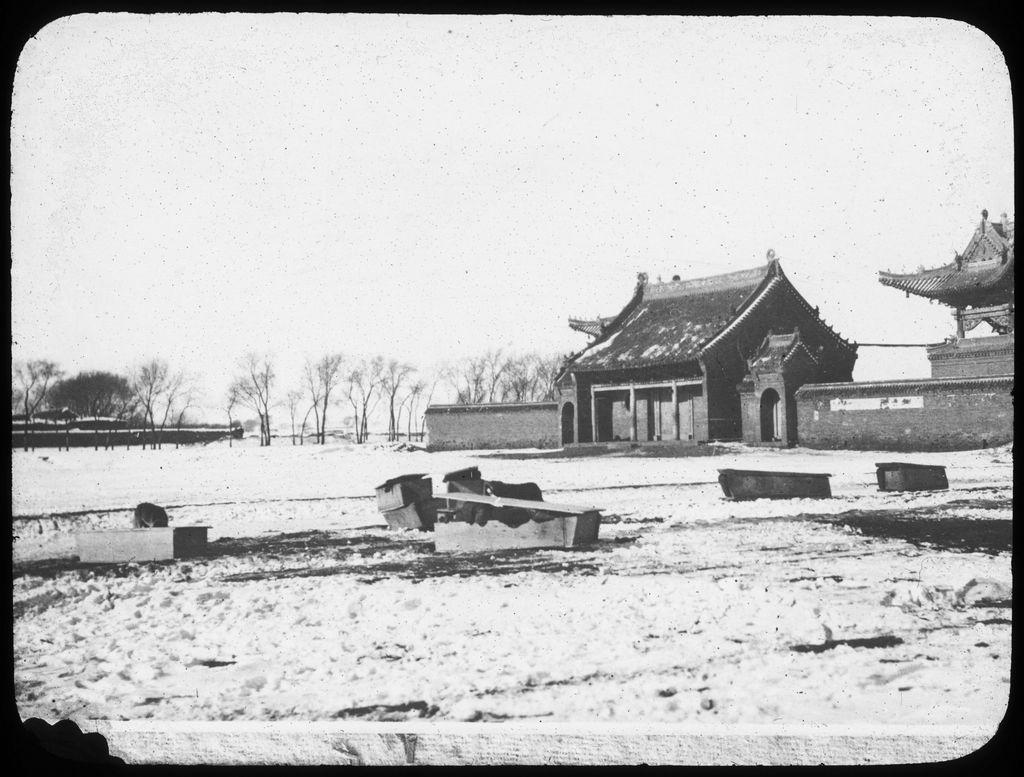What type of structures are visible in the image? There are houses in the image. What type of vegetation is present in the image? There are trees in the image. What objects can be seen on the ground in the image? There are boxes on the ground in the image. What type of jam is being served at the queen's table in the image? There is no queen, table, or jam present in the image. 